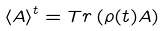Convert formula to latex. <formula><loc_0><loc_0><loc_500><loc_500>\left \langle A \right \rangle ^ { t } = T r \left ( \rho ( t ) A \right )</formula> 